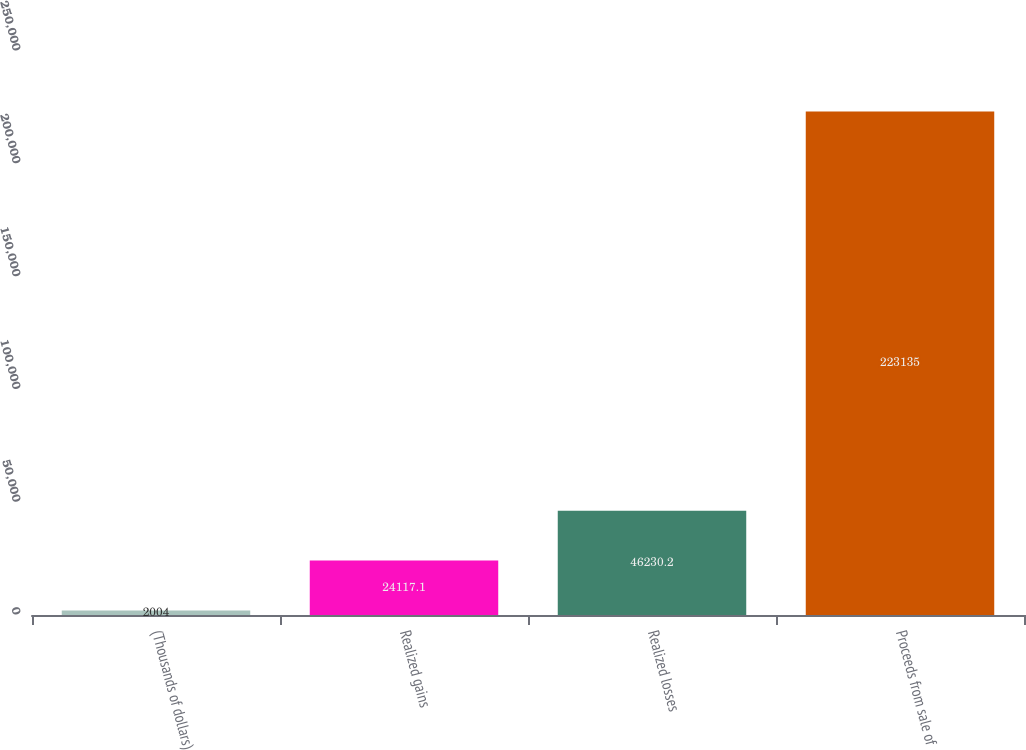Convert chart to OTSL. <chart><loc_0><loc_0><loc_500><loc_500><bar_chart><fcel>(Thousands of dollars)<fcel>Realized gains<fcel>Realized losses<fcel>Proceeds from sale of<nl><fcel>2004<fcel>24117.1<fcel>46230.2<fcel>223135<nl></chart> 